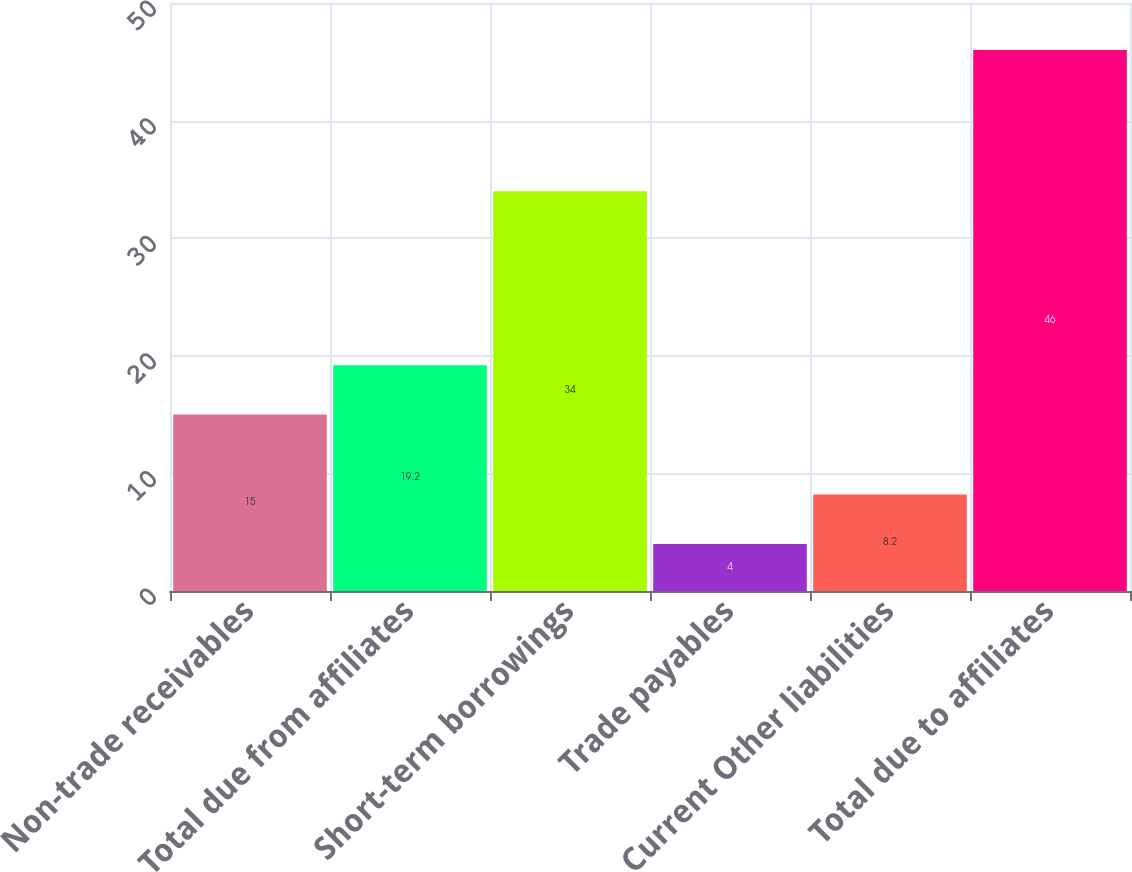Convert chart to OTSL. <chart><loc_0><loc_0><loc_500><loc_500><bar_chart><fcel>Non-trade receivables<fcel>Total due from affiliates<fcel>Short-term borrowings<fcel>Trade payables<fcel>Current Other liabilities<fcel>Total due to affiliates<nl><fcel>15<fcel>19.2<fcel>34<fcel>4<fcel>8.2<fcel>46<nl></chart> 